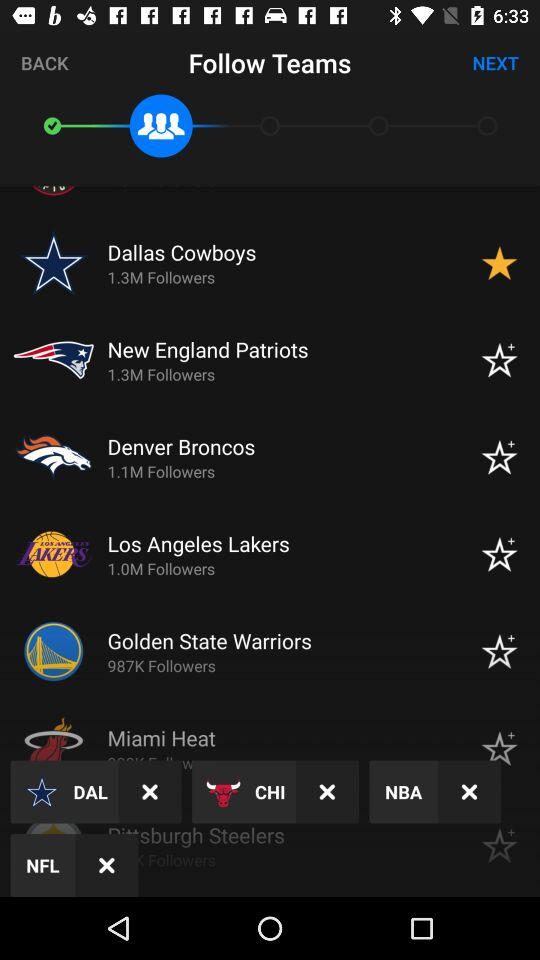What team has 1.0M followers? The team is the Los Angeles Lakers. 